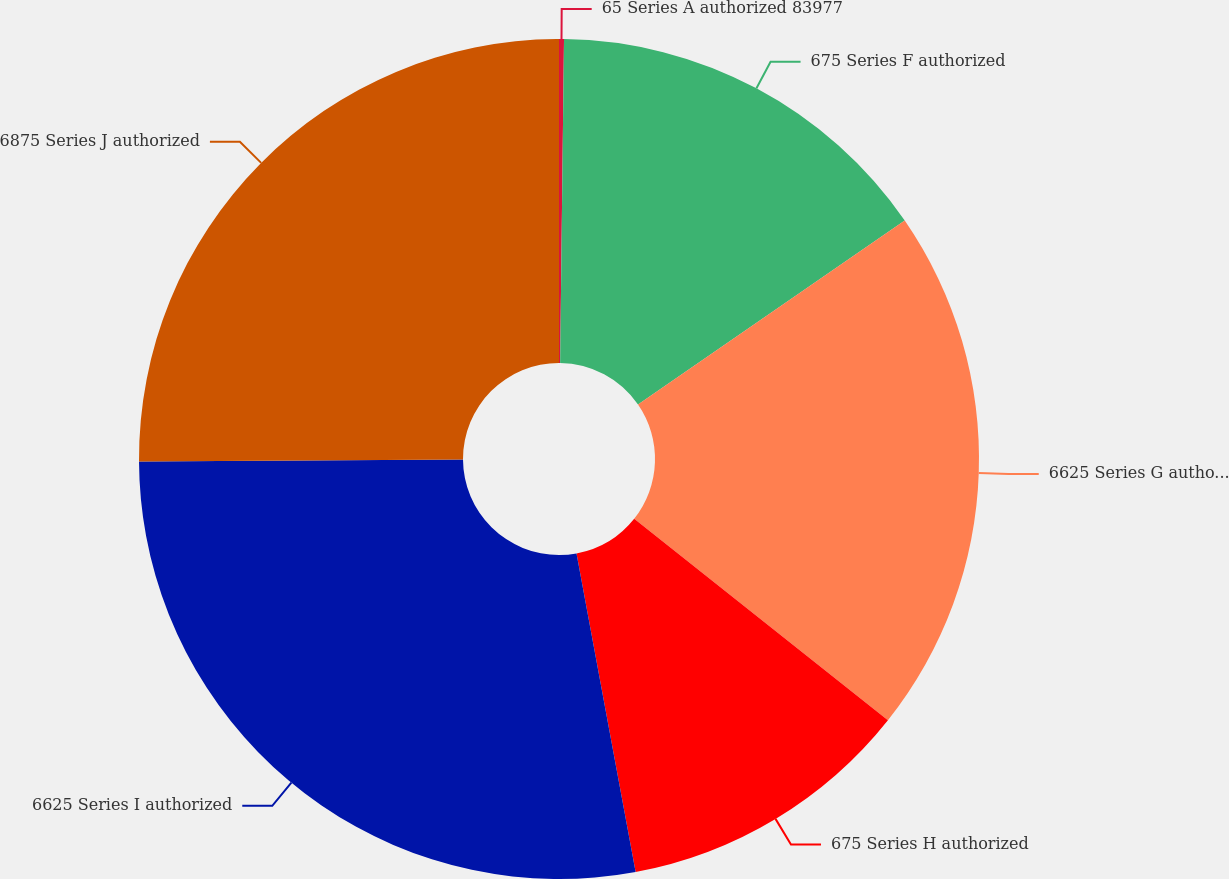<chart> <loc_0><loc_0><loc_500><loc_500><pie_chart><fcel>65 Series A authorized 83977<fcel>675 Series F authorized<fcel>6625 Series G authorized<fcel>675 Series H authorized<fcel>6625 Series I authorized<fcel>6875 Series J authorized<nl><fcel>0.19%<fcel>15.2%<fcel>20.29%<fcel>11.4%<fcel>27.83%<fcel>25.09%<nl></chart> 